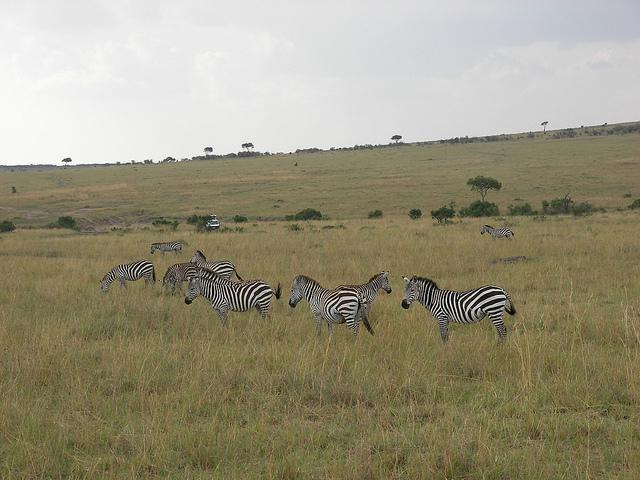How many zebras are there?
Give a very brief answer. 9. How many zebra's are there?
Give a very brief answer. 9. How many zebras are in the picture?
Give a very brief answer. 3. 